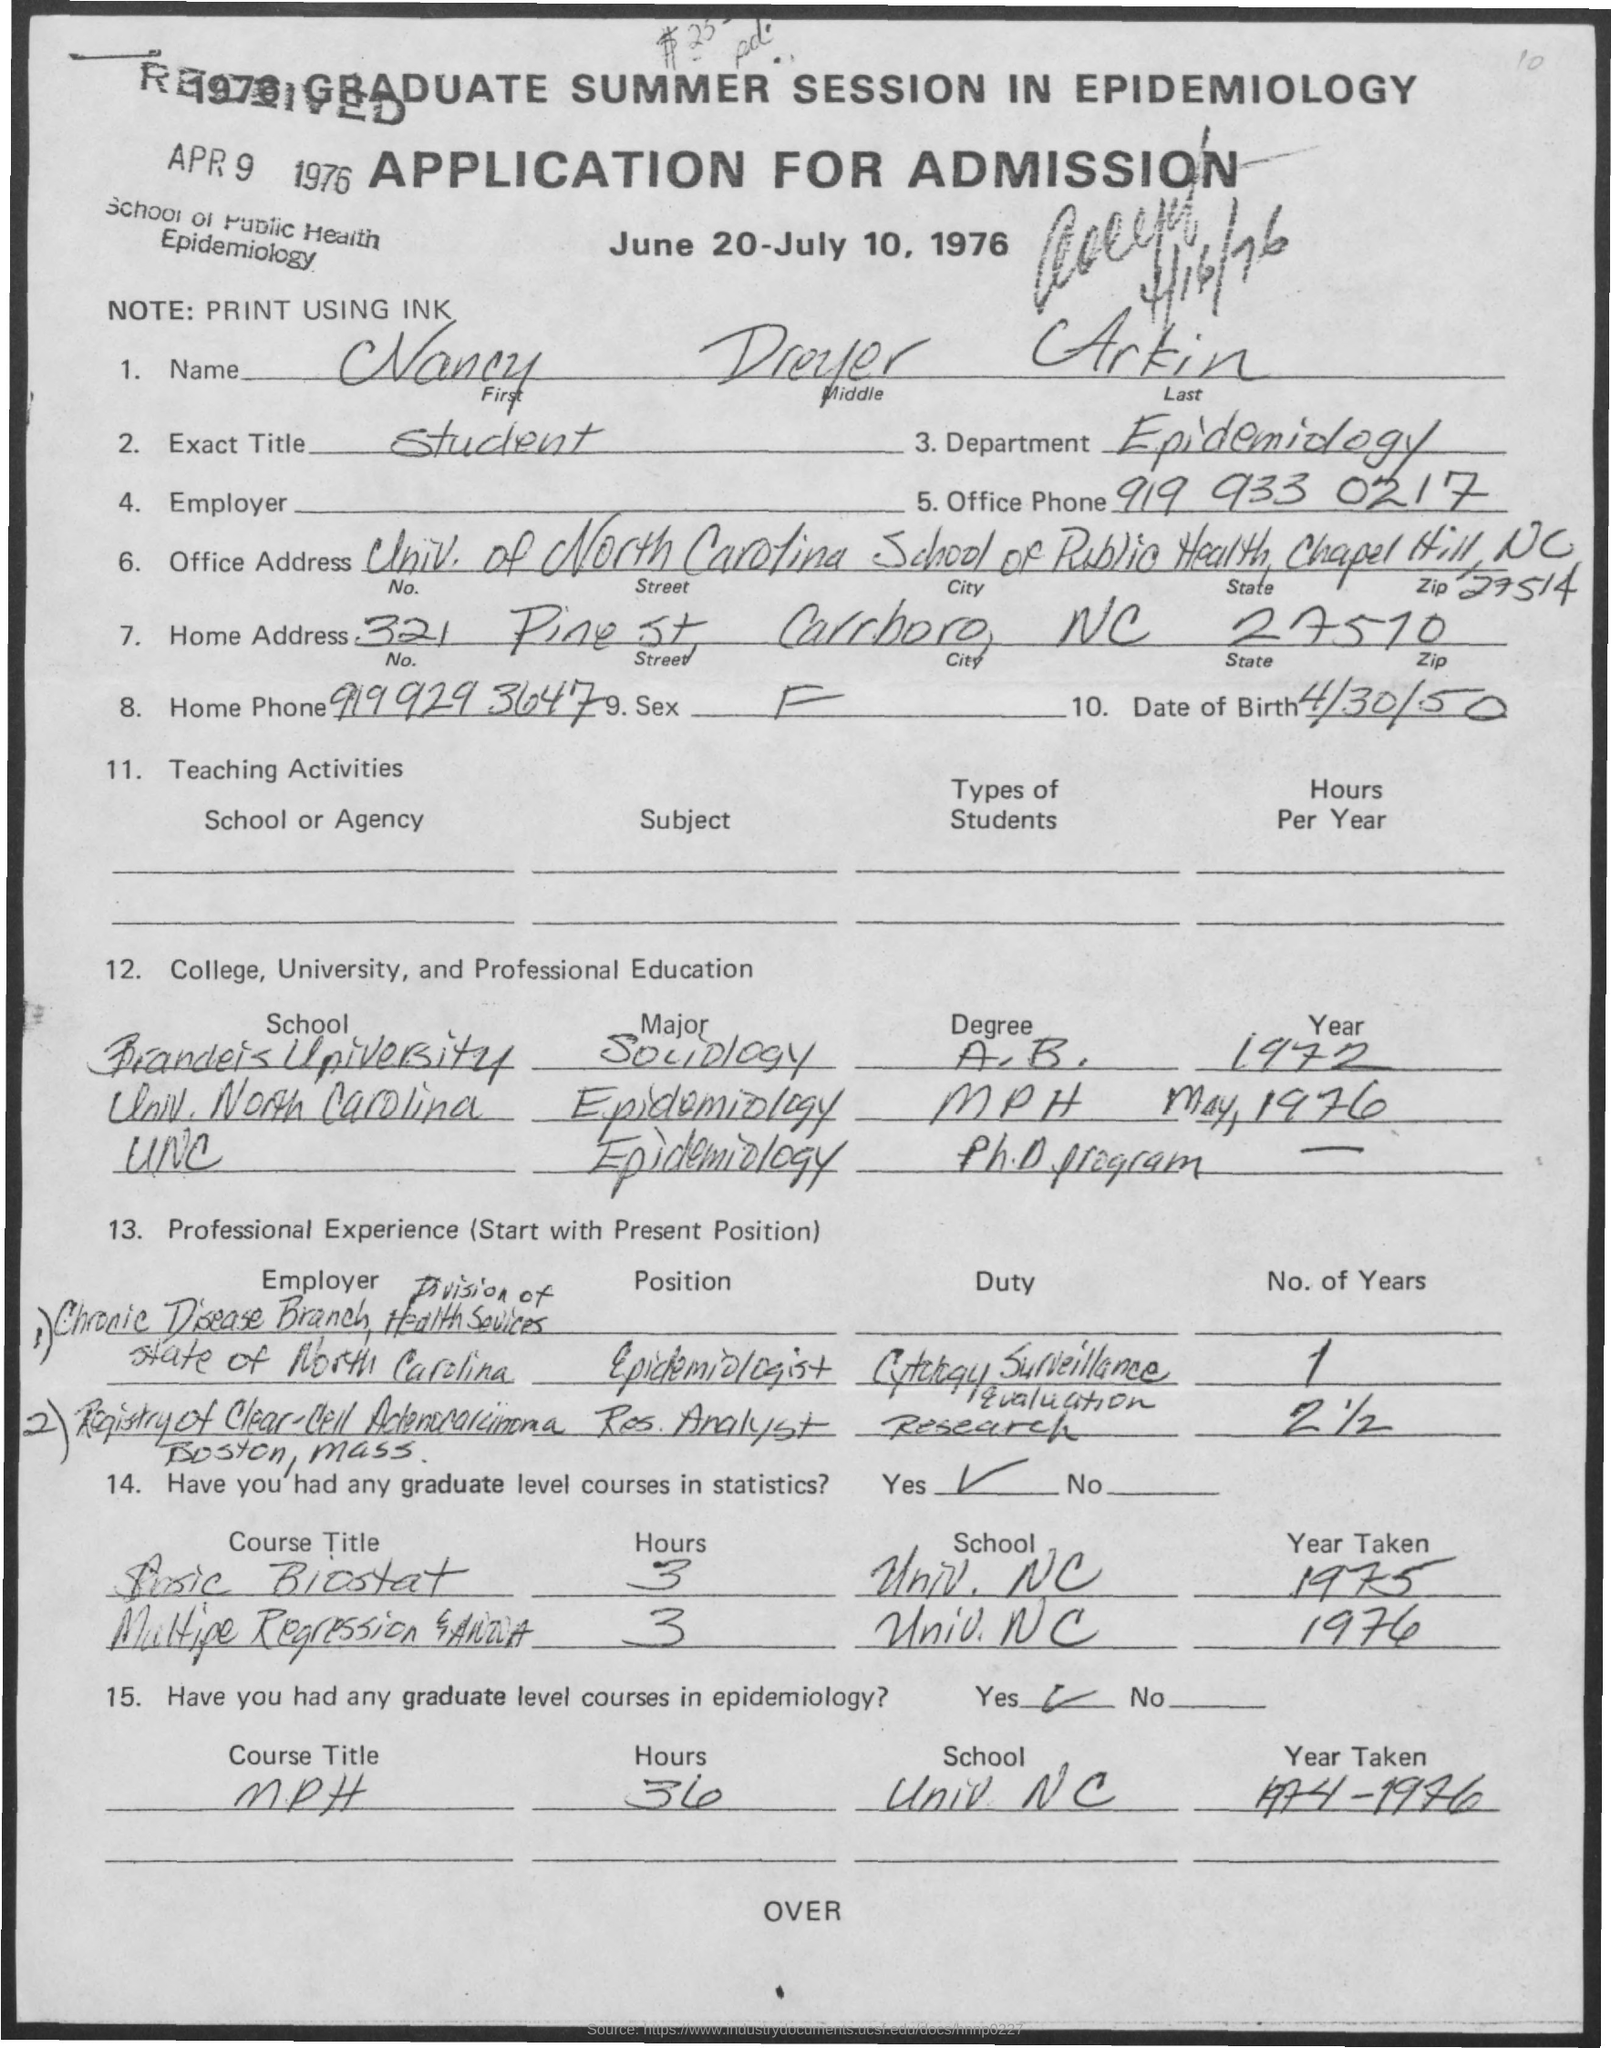What is the exact title ?
Provide a succinct answer. Student. Which department  they belong ?
Your answer should be compact. Epidemiology. What is the date of birth
Your response must be concise. 4/30/50. What is the office phone number ?
Ensure brevity in your answer.  919 933 0217. What is the home phone number ?
Provide a succinct answer. 9199293647. 